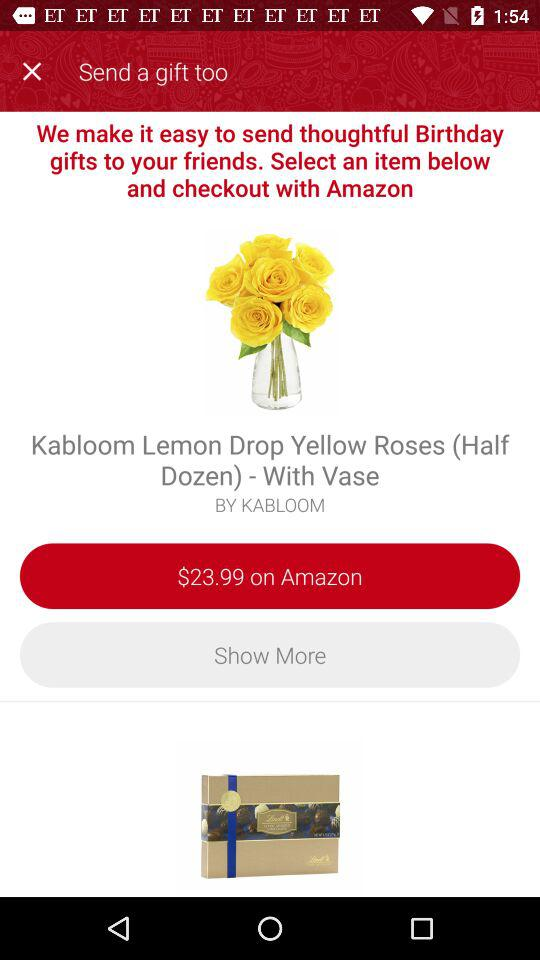What is the price of the product on Amazon? The price is $23.99. 